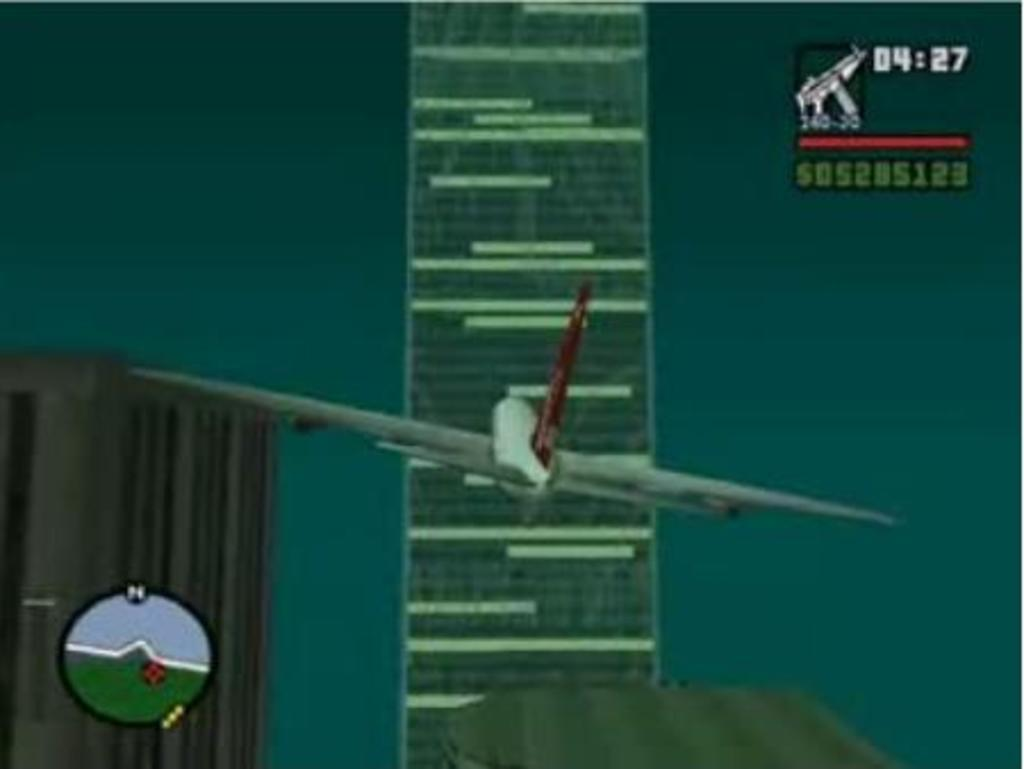<image>
Write a terse but informative summary of the picture. A flight simulator game with 04:27 in the corner and a tower in front of the plane 